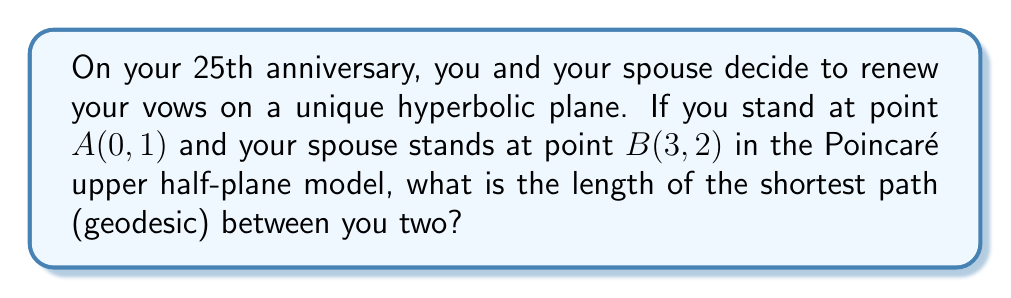Give your solution to this math problem. To solve this problem, we'll follow these steps:

1) In the Poincaré upper half-plane model, geodesics are either vertical lines or semicircles with centers on the x-axis.

2) Since A and B are not on the same vertical line, the geodesic will be a semicircle.

3) To find this semicircle, we need to determine its center (h, 0) and radius r.

4) The equation of a circle passing through (0, 1) and (3, 2) is:
   $$(x-h)^2 + y^2 = r^2$$

5) Substituting the two points:
   $$(0-h)^2 + 1^2 = r^2$$
   $$(3-h)^2 + 2^2 = r^2$$

6) Subtracting these equations:
   $$(3-h)^2 - (-h)^2 = 4 - 1$$
   $$9 - 6h + h^2 - h^2 = 3$$
   $$9 - 6h = 3$$
   $$6h = 6$$
   $$h = 1$$

7) Substituting back:
   $$(-1)^2 + 1^2 = r^2$$
   $$r^2 = 2$$
   $$r = \sqrt{2}$$

8) The geodesic is a semicircle centered at (1, 0) with radius $\sqrt{2}$.

9) The length of a geodesic in the Poincaré upper half-plane model is given by:
   $$d = |\ln(\frac{a}{b})|$$
   where $a$ and $b$ are the points where the geodesic intersects the y-axis.

10) These points are:
    $$a = 1 + \sqrt{2}$$
    $$b = 1 - \sqrt{2}$$

11) Therefore, the length is:
    $$d = |\ln(\frac{1 + \sqrt{2}}{1 - \sqrt{2}})|$$

12) Simplifying:
    $$d = |\ln(\frac{(1 + \sqrt{2})^2}{(1 + \sqrt{2})(1 - \sqrt{2})})| = |\ln(3 + 2\sqrt{2})|$$
Answer: $|\ln(3 + 2\sqrt{2})|$ 